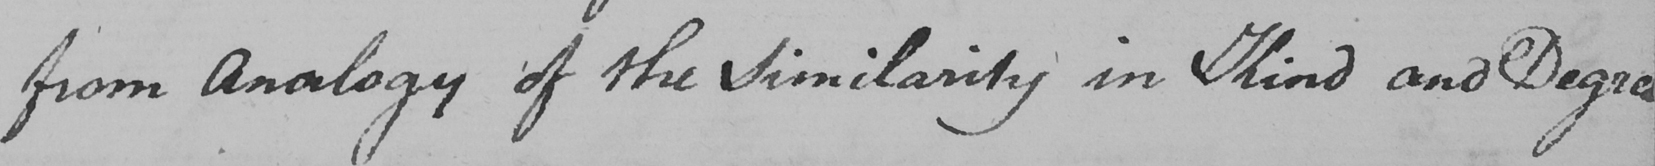What is written in this line of handwriting? from Analogy of the Similarity in Kind and Degree 